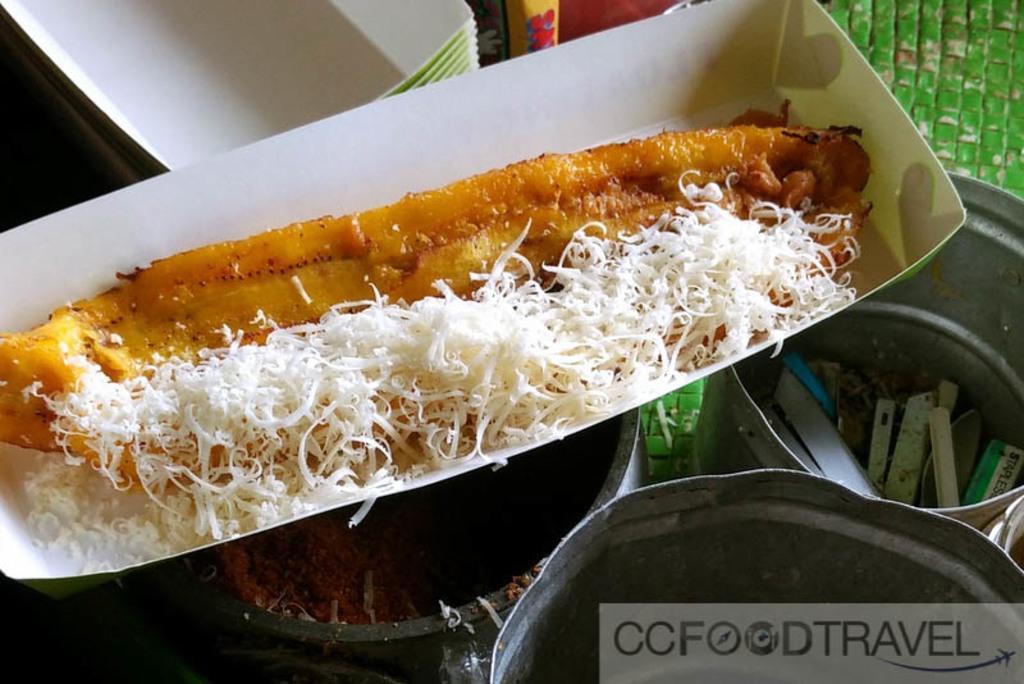Describe this image in one or two sentences. Here we can see a food item in a box on a bowl with food in it. On the right at the bottom corner we can see two tins with some items in it and at the top we can see boxes and other objects. 